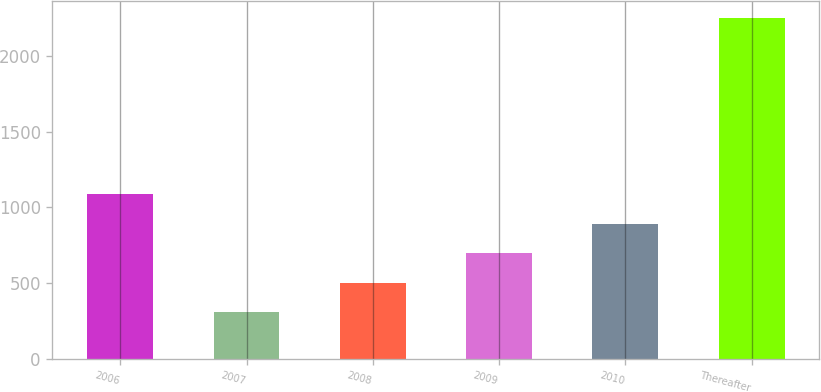Convert chart to OTSL. <chart><loc_0><loc_0><loc_500><loc_500><bar_chart><fcel>2006<fcel>2007<fcel>2008<fcel>2009<fcel>2010<fcel>Thereafter<nl><fcel>1086.8<fcel>308<fcel>502.7<fcel>697.4<fcel>892.1<fcel>2255<nl></chart> 